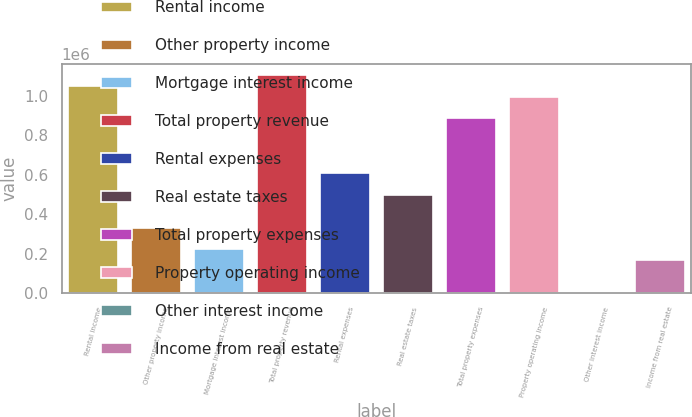<chart> <loc_0><loc_0><loc_500><loc_500><bar_chart><fcel>Rental income<fcel>Other property income<fcel>Mortgage interest income<fcel>Total property revenue<fcel>Rental expenses<fcel>Real estate taxes<fcel>Total property expenses<fcel>Property operating income<fcel>Other interest income<fcel>Income from real estate<nl><fcel>1.05062e+06<fcel>331923<fcel>221354<fcel>1.1059e+06<fcel>608343<fcel>497775<fcel>884764<fcel>995332<fcel>218<fcel>166070<nl></chart> 